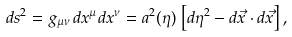<formula> <loc_0><loc_0><loc_500><loc_500>d s ^ { 2 } = g _ { \mu \nu } \, d x ^ { \mu } d x ^ { \nu } = a ^ { 2 } ( \eta ) \, \left [ d \eta ^ { 2 } - d \vec { x } \cdot d \vec { x } \right ] ,</formula> 